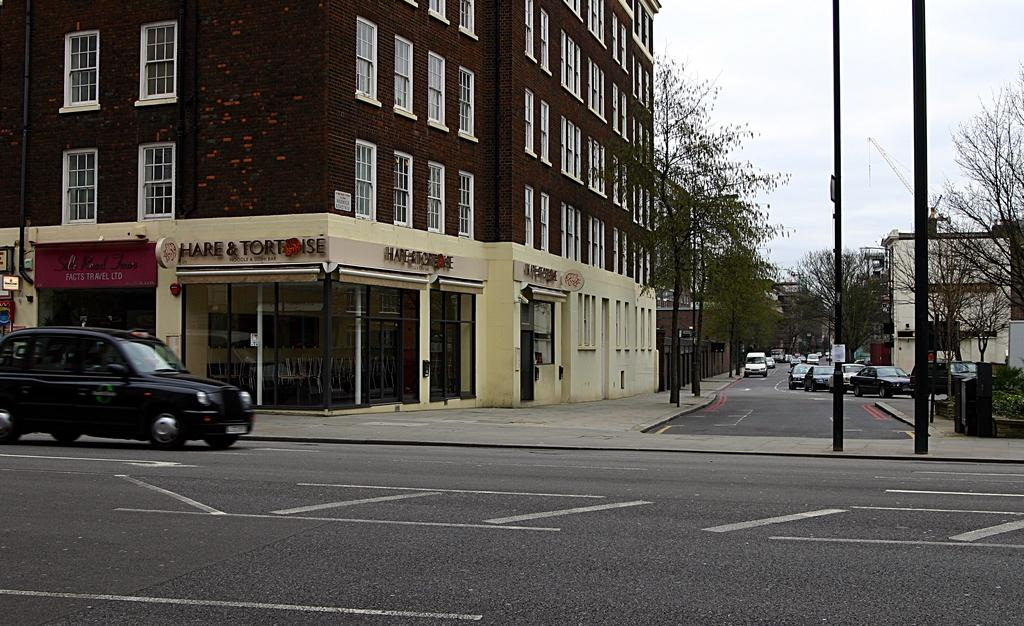Provide a one-sentence caption for the provided image. A street scene shows the facade of a noodle restaurant. 